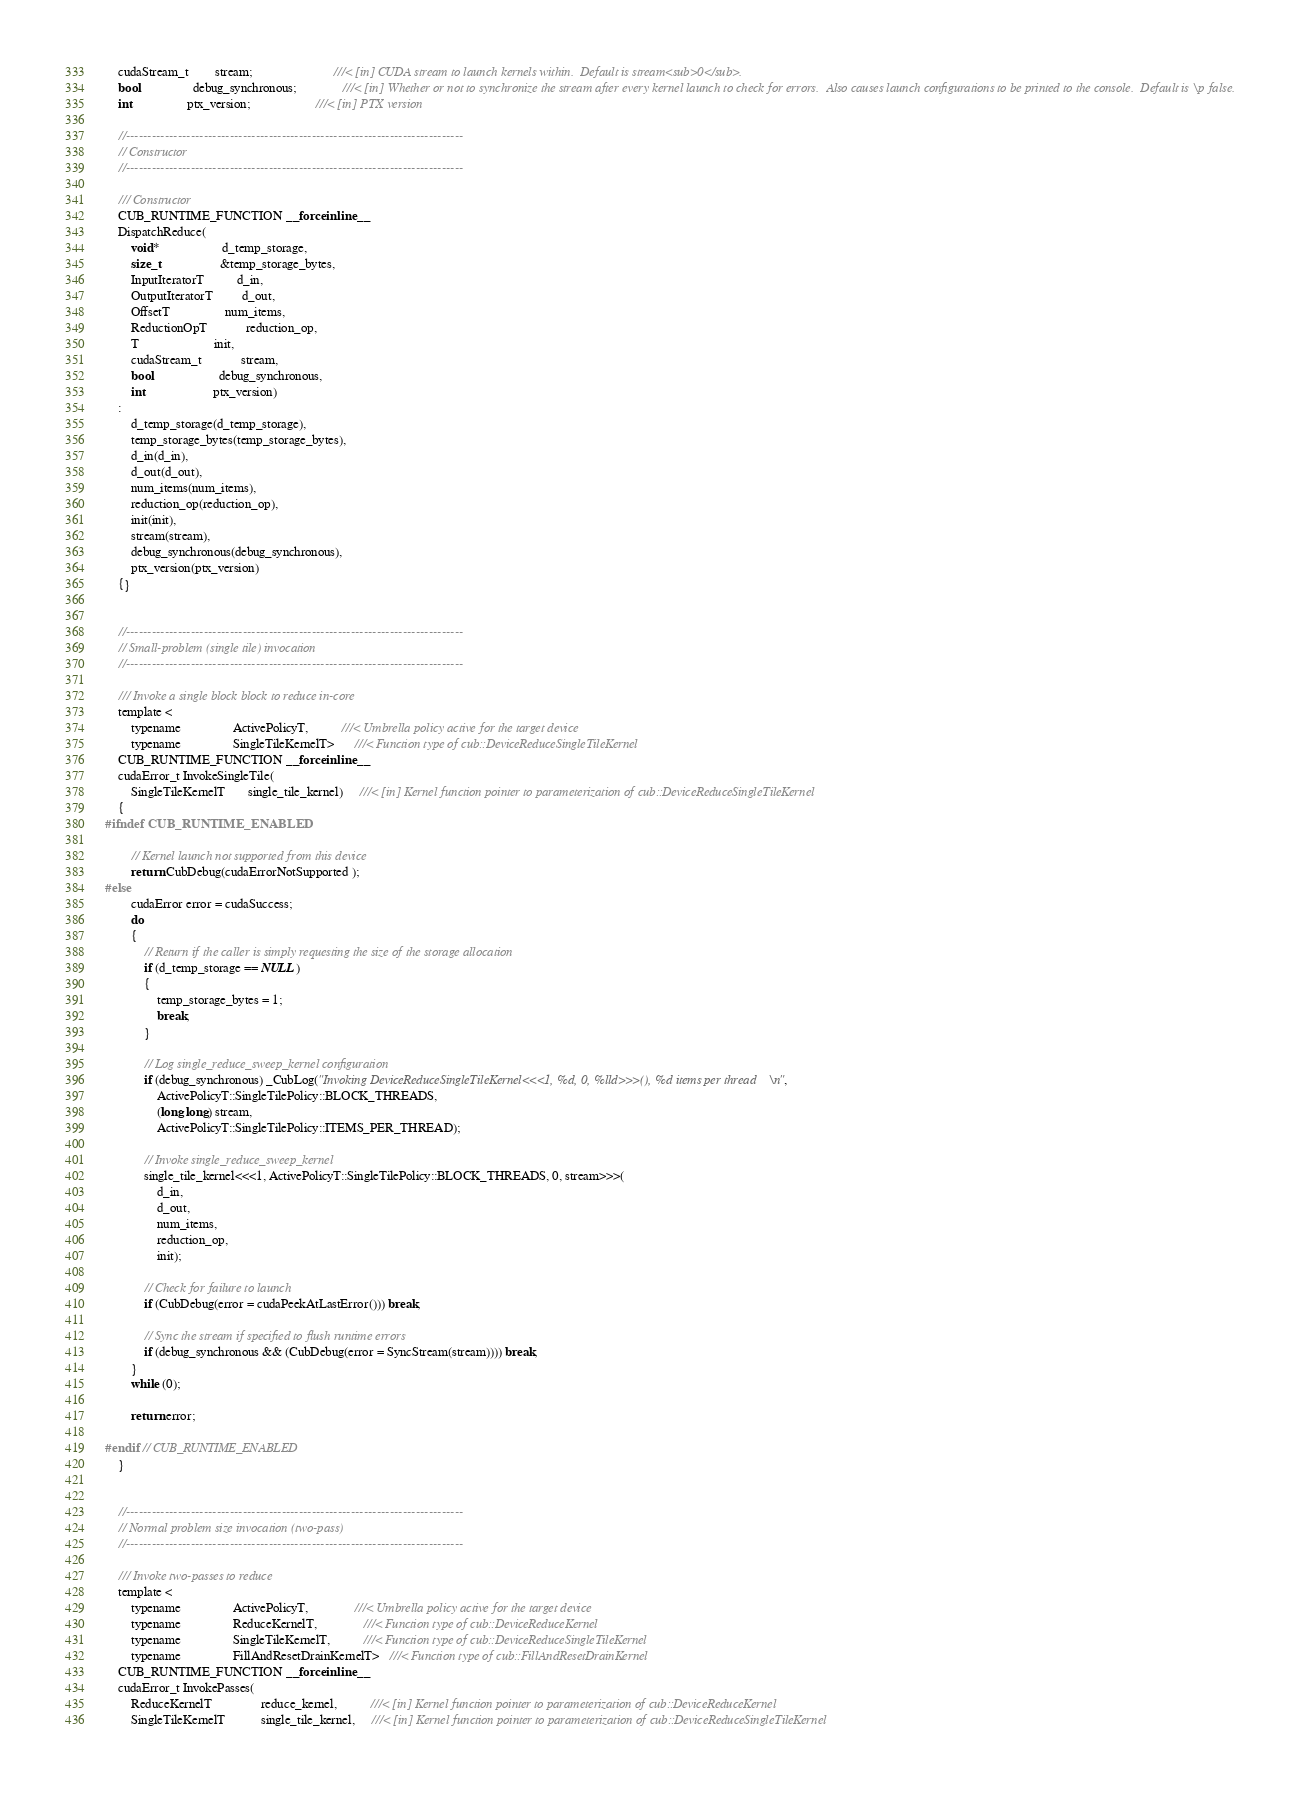Convert code to text. <code><loc_0><loc_0><loc_500><loc_500><_Cuda_>    cudaStream_t        stream;                         ///< [in] CUDA stream to launch kernels within.  Default is stream<sub>0</sub>.
    bool                debug_synchronous;              ///< [in] Whether or not to synchronize the stream after every kernel launch to check for errors.  Also causes launch configurations to be printed to the console.  Default is \p false.
    int                 ptx_version;                    ///< [in] PTX version

    //------------------------------------------------------------------------------
    // Constructor
    //------------------------------------------------------------------------------

    /// Constructor
    CUB_RUNTIME_FUNCTION __forceinline__
    DispatchReduce(
        void*                   d_temp_storage,
        size_t                  &temp_storage_bytes,
        InputIteratorT          d_in,
        OutputIteratorT         d_out,
        OffsetT                 num_items,
        ReductionOpT            reduction_op,
        T                       init,
        cudaStream_t            stream,
        bool                    debug_synchronous,
        int                     ptx_version)
    :
        d_temp_storage(d_temp_storage),
        temp_storage_bytes(temp_storage_bytes),
        d_in(d_in),
        d_out(d_out),
        num_items(num_items),
        reduction_op(reduction_op),
        init(init),
        stream(stream),
        debug_synchronous(debug_synchronous),
        ptx_version(ptx_version)
    {}


    //------------------------------------------------------------------------------
    // Small-problem (single tile) invocation
    //------------------------------------------------------------------------------

    /// Invoke a single block block to reduce in-core
    template <
        typename                ActivePolicyT,          ///< Umbrella policy active for the target device
        typename                SingleTileKernelT>      ///< Function type of cub::DeviceReduceSingleTileKernel
    CUB_RUNTIME_FUNCTION __forceinline__
    cudaError_t InvokeSingleTile(
        SingleTileKernelT       single_tile_kernel)     ///< [in] Kernel function pointer to parameterization of cub::DeviceReduceSingleTileKernel
    {
#ifndef CUB_RUNTIME_ENABLED

        // Kernel launch not supported from this device
        return CubDebug(cudaErrorNotSupported );
#else
        cudaError error = cudaSuccess;
        do
        {
            // Return if the caller is simply requesting the size of the storage allocation
            if (d_temp_storage == NULL)
            {
                temp_storage_bytes = 1;
                break;
            }

            // Log single_reduce_sweep_kernel configuration
            if (debug_synchronous) _CubLog("Invoking DeviceReduceSingleTileKernel<<<1, %d, 0, %lld>>>(), %d items per thread\n",
                ActivePolicyT::SingleTilePolicy::BLOCK_THREADS,
                (long long) stream,
                ActivePolicyT::SingleTilePolicy::ITEMS_PER_THREAD);

            // Invoke single_reduce_sweep_kernel
            single_tile_kernel<<<1, ActivePolicyT::SingleTilePolicy::BLOCK_THREADS, 0, stream>>>(
                d_in,
                d_out,
                num_items,
                reduction_op,
                init);

            // Check for failure to launch
            if (CubDebug(error = cudaPeekAtLastError())) break;

            // Sync the stream if specified to flush runtime errors
            if (debug_synchronous && (CubDebug(error = SyncStream(stream)))) break;
        }
        while (0);

        return error;

#endif // CUB_RUNTIME_ENABLED
    }


    //------------------------------------------------------------------------------
    // Normal problem size invocation (two-pass)
    //------------------------------------------------------------------------------

    /// Invoke two-passes to reduce
    template <
        typename                ActivePolicyT,              ///< Umbrella policy active for the target device
        typename                ReduceKernelT,              ///< Function type of cub::DeviceReduceKernel
        typename                SingleTileKernelT,          ///< Function type of cub::DeviceReduceSingleTileKernel
        typename                FillAndResetDrainKernelT>   ///< Function type of cub::FillAndResetDrainKernel
    CUB_RUNTIME_FUNCTION __forceinline__
    cudaError_t InvokePasses(
        ReduceKernelT               reduce_kernel,          ///< [in] Kernel function pointer to parameterization of cub::DeviceReduceKernel
        SingleTileKernelT           single_tile_kernel,     ///< [in] Kernel function pointer to parameterization of cub::DeviceReduceSingleTileKernel</code> 